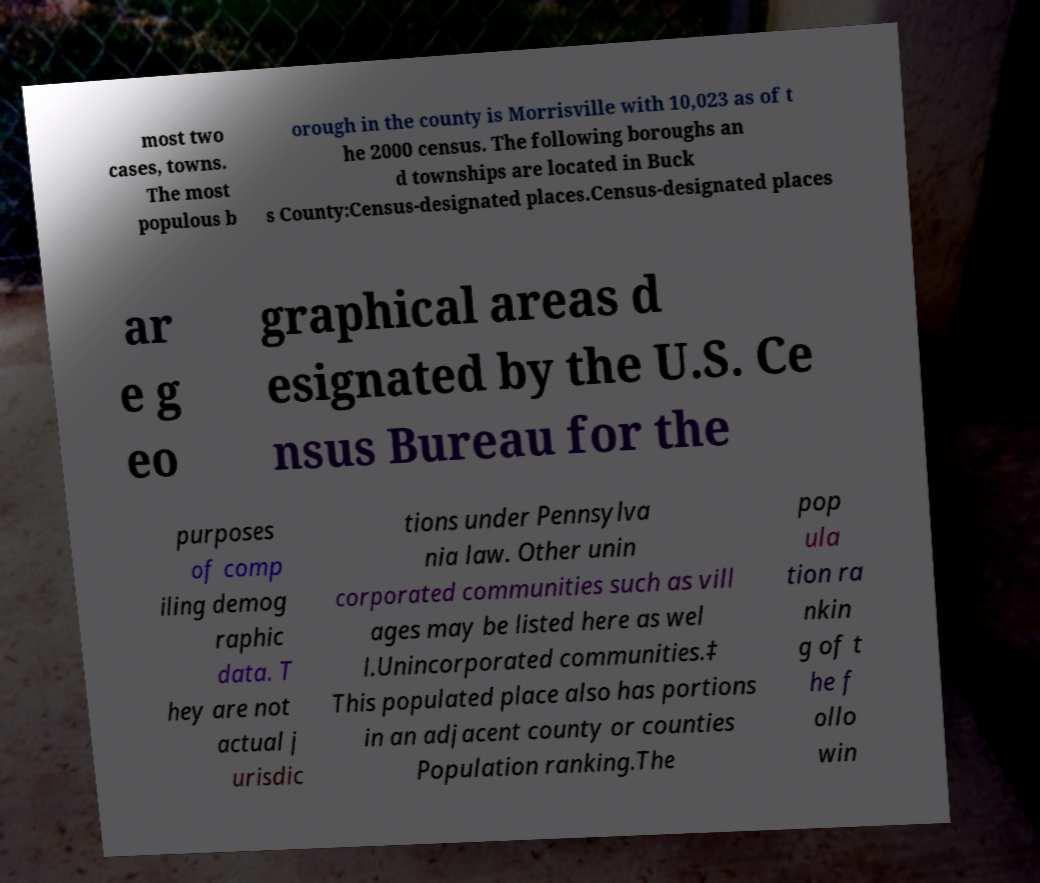Could you extract and type out the text from this image? most two cases, towns. The most populous b orough in the county is Morrisville with 10,023 as of t he 2000 census. The following boroughs an d townships are located in Buck s County:Census-designated places.Census-designated places ar e g eo graphical areas d esignated by the U.S. Ce nsus Bureau for the purposes of comp iling demog raphic data. T hey are not actual j urisdic tions under Pennsylva nia law. Other unin corporated communities such as vill ages may be listed here as wel l.Unincorporated communities.‡ This populated place also has portions in an adjacent county or counties Population ranking.The pop ula tion ra nkin g of t he f ollo win 